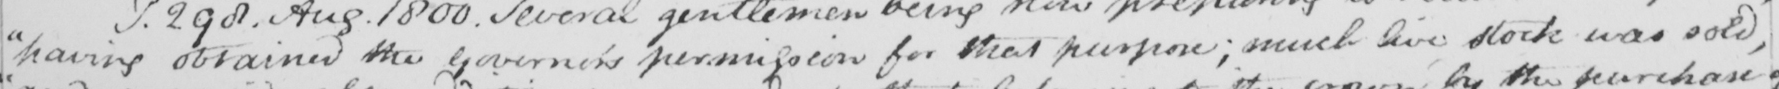Transcribe the text shown in this historical manuscript line. " having obtained the Governor ' s permission for that purpose ; much live stock was sold , 